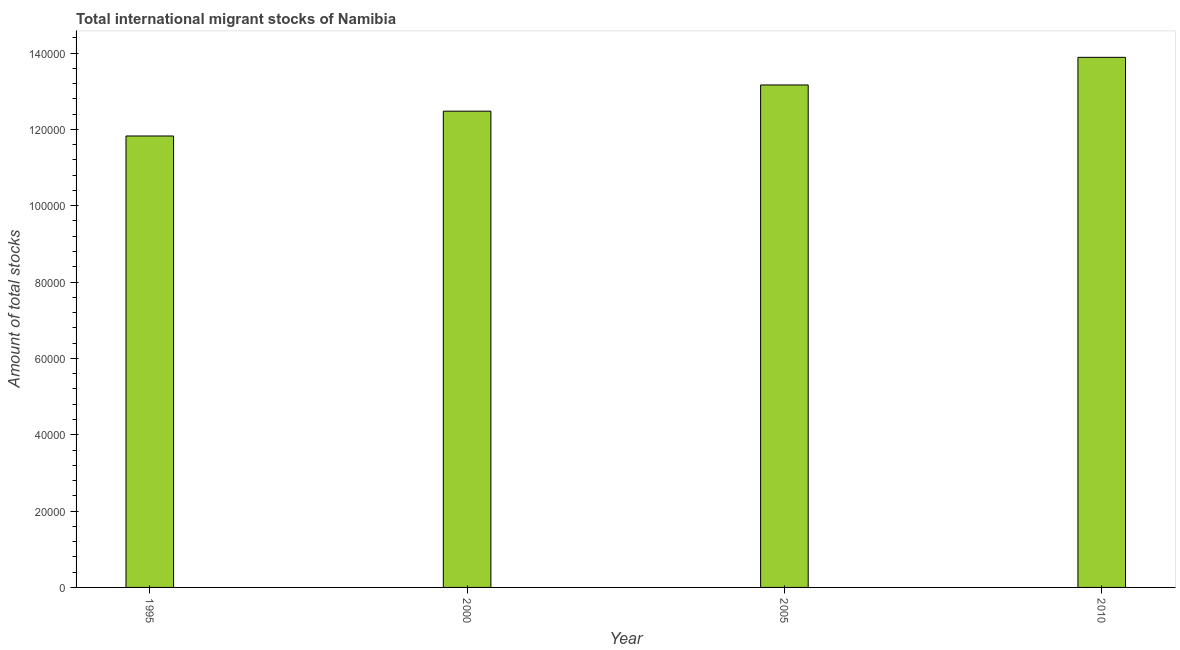Does the graph contain any zero values?
Your answer should be very brief. No. What is the title of the graph?
Your answer should be compact. Total international migrant stocks of Namibia. What is the label or title of the Y-axis?
Offer a very short reply. Amount of total stocks. What is the total number of international migrant stock in 1995?
Provide a succinct answer. 1.18e+05. Across all years, what is the maximum total number of international migrant stock?
Your response must be concise. 1.39e+05. Across all years, what is the minimum total number of international migrant stock?
Your answer should be compact. 1.18e+05. What is the sum of the total number of international migrant stock?
Give a very brief answer. 5.14e+05. What is the difference between the total number of international migrant stock in 2000 and 2005?
Your response must be concise. -6863. What is the average total number of international migrant stock per year?
Make the answer very short. 1.28e+05. What is the median total number of international migrant stock?
Make the answer very short. 1.28e+05. What is the ratio of the total number of international migrant stock in 1995 to that in 2005?
Keep it short and to the point. 0.9. Is the total number of international migrant stock in 1995 less than that in 2000?
Provide a succinct answer. Yes. What is the difference between the highest and the second highest total number of international migrant stock?
Make the answer very short. 7240. Is the sum of the total number of international migrant stock in 2000 and 2010 greater than the maximum total number of international migrant stock across all years?
Ensure brevity in your answer.  Yes. What is the difference between the highest and the lowest total number of international migrant stock?
Ensure brevity in your answer.  2.06e+04. In how many years, is the total number of international migrant stock greater than the average total number of international migrant stock taken over all years?
Your response must be concise. 2. How many bars are there?
Your answer should be compact. 4. Are all the bars in the graph horizontal?
Give a very brief answer. No. What is the difference between two consecutive major ticks on the Y-axis?
Provide a succinct answer. 2.00e+04. What is the Amount of total stocks of 1995?
Offer a terse response. 1.18e+05. What is the Amount of total stocks of 2000?
Provide a short and direct response. 1.25e+05. What is the Amount of total stocks of 2005?
Give a very brief answer. 1.32e+05. What is the Amount of total stocks in 2010?
Your answer should be very brief. 1.39e+05. What is the difference between the Amount of total stocks in 1995 and 2000?
Offer a very short reply. -6505. What is the difference between the Amount of total stocks in 1995 and 2005?
Your answer should be compact. -1.34e+04. What is the difference between the Amount of total stocks in 1995 and 2010?
Keep it short and to the point. -2.06e+04. What is the difference between the Amount of total stocks in 2000 and 2005?
Keep it short and to the point. -6863. What is the difference between the Amount of total stocks in 2000 and 2010?
Provide a short and direct response. -1.41e+04. What is the difference between the Amount of total stocks in 2005 and 2010?
Your response must be concise. -7240. What is the ratio of the Amount of total stocks in 1995 to that in 2000?
Your answer should be compact. 0.95. What is the ratio of the Amount of total stocks in 1995 to that in 2005?
Keep it short and to the point. 0.9. What is the ratio of the Amount of total stocks in 1995 to that in 2010?
Provide a short and direct response. 0.85. What is the ratio of the Amount of total stocks in 2000 to that in 2005?
Ensure brevity in your answer.  0.95. What is the ratio of the Amount of total stocks in 2000 to that in 2010?
Your answer should be very brief. 0.9. What is the ratio of the Amount of total stocks in 2005 to that in 2010?
Your answer should be very brief. 0.95. 